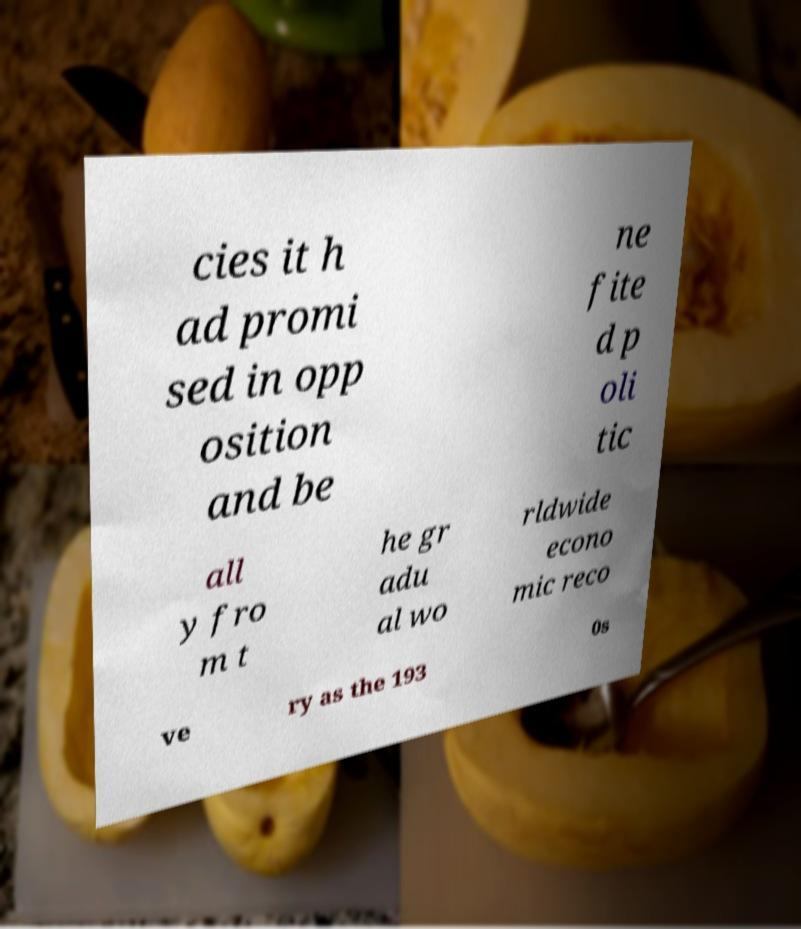For documentation purposes, I need the text within this image transcribed. Could you provide that? cies it h ad promi sed in opp osition and be ne fite d p oli tic all y fro m t he gr adu al wo rldwide econo mic reco ve ry as the 193 0s 